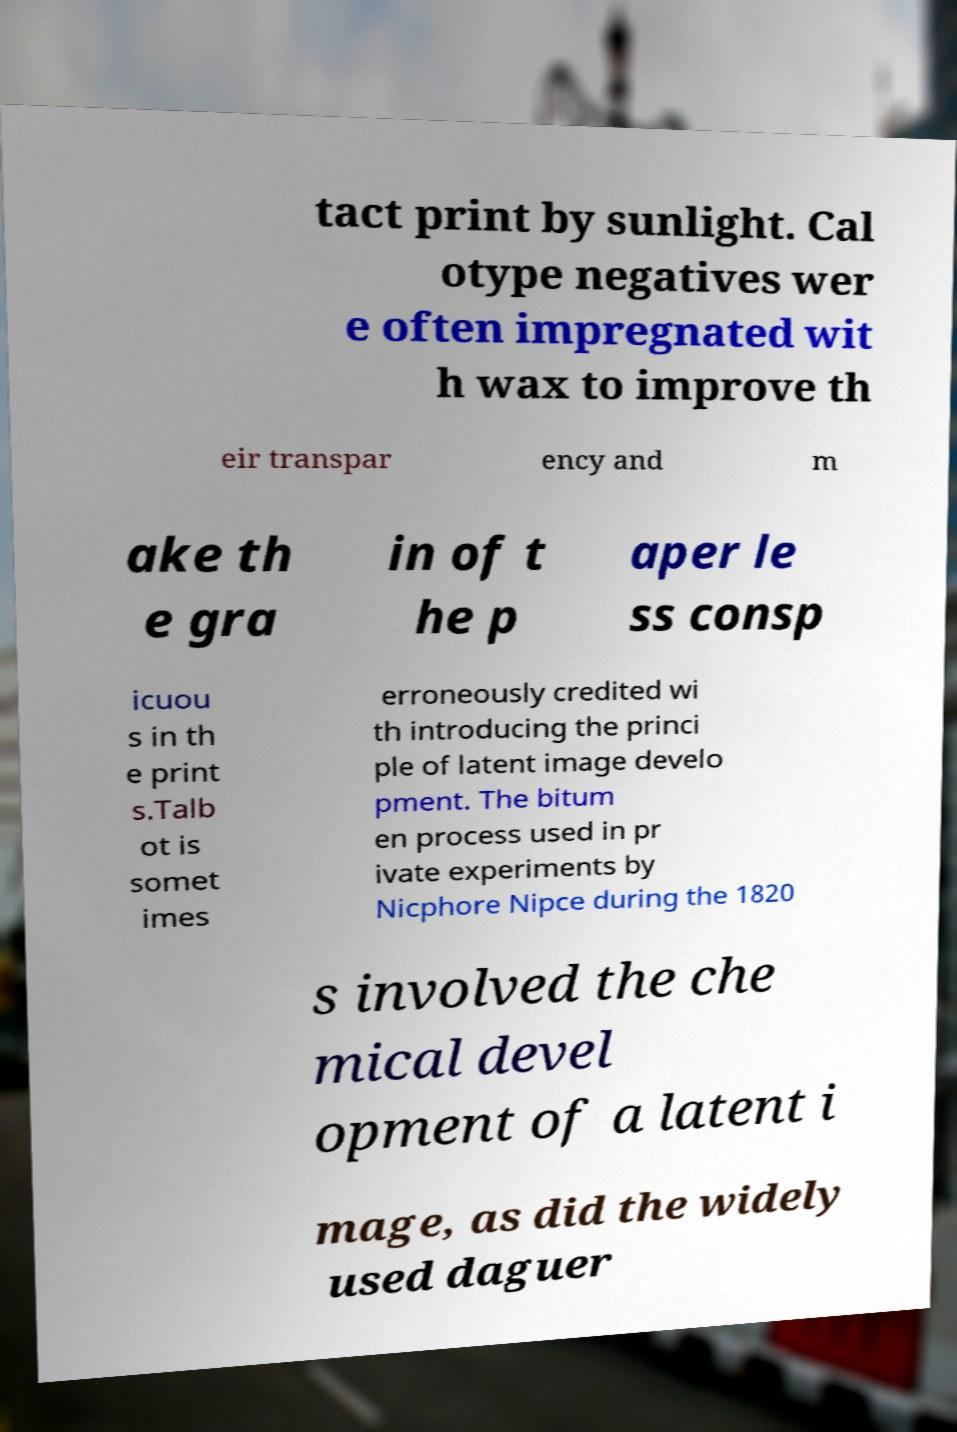Could you assist in decoding the text presented in this image and type it out clearly? tact print by sunlight. Cal otype negatives wer e often impregnated wit h wax to improve th eir transpar ency and m ake th e gra in of t he p aper le ss consp icuou s in th e print s.Talb ot is somet imes erroneously credited wi th introducing the princi ple of latent image develo pment. The bitum en process used in pr ivate experiments by Nicphore Nipce during the 1820 s involved the che mical devel opment of a latent i mage, as did the widely used daguer 